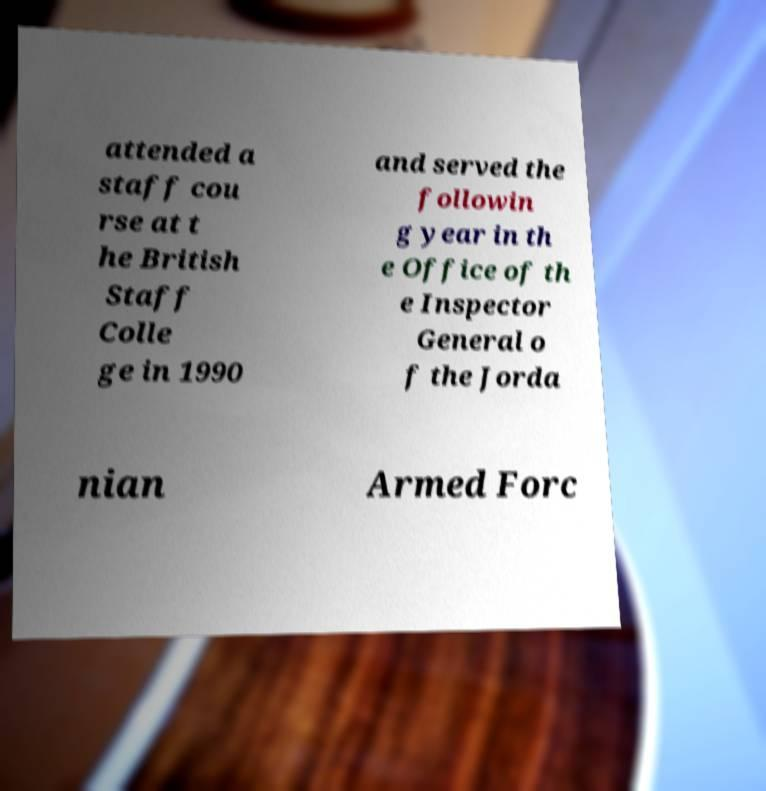Please identify and transcribe the text found in this image. attended a staff cou rse at t he British Staff Colle ge in 1990 and served the followin g year in th e Office of th e Inspector General o f the Jorda nian Armed Forc 